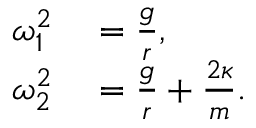Convert formula to latex. <formula><loc_0><loc_0><loc_500><loc_500>\begin{array} { r l } { \omega _ { 1 } ^ { 2 } } & = \frac { g } { r } , } \\ { \omega _ { 2 } ^ { 2 } } & = \frac { g } { r } + \frac { 2 \kappa } { m } . } \end{array}</formula> 